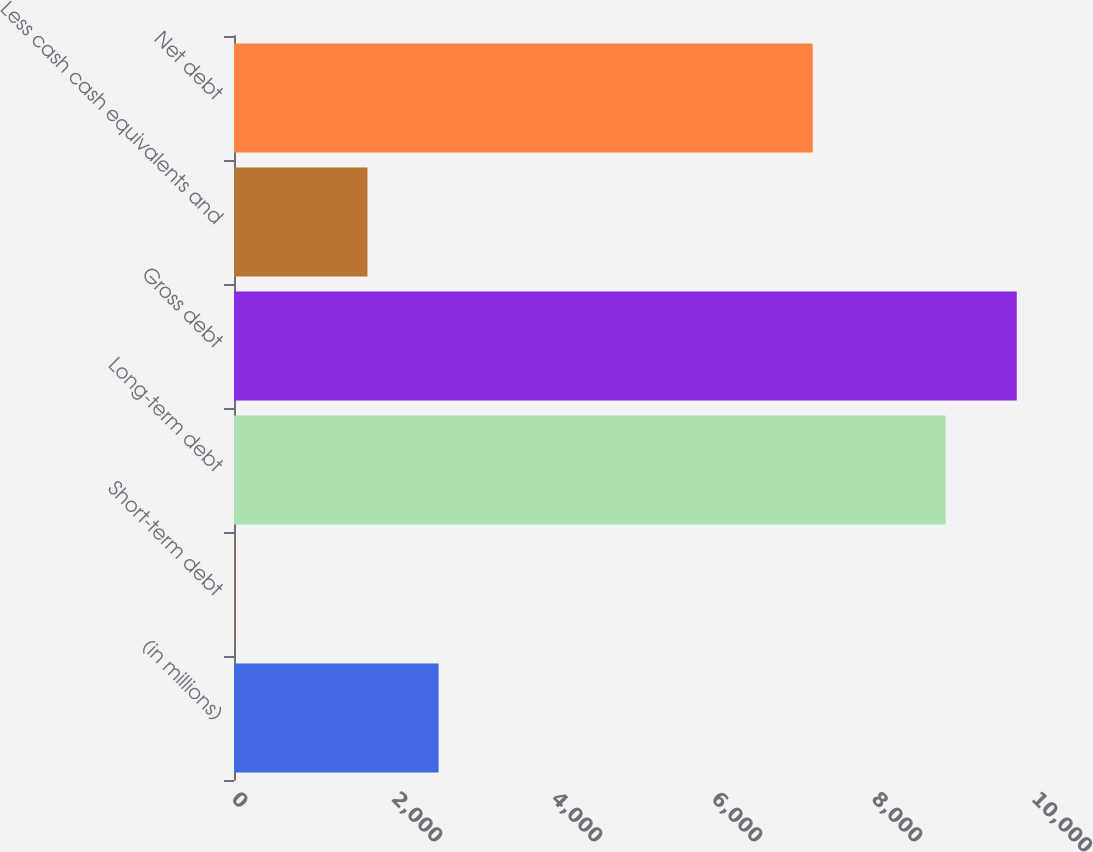<chart> <loc_0><loc_0><loc_500><loc_500><bar_chart><fcel>(in millions)<fcel>Short-term debt<fcel>Long-term debt<fcel>Gross debt<fcel>Less cash cash equivalents and<fcel>Net debt<nl><fcel>2557.5<fcel>7<fcel>8895<fcel>9784.5<fcel>1668<fcel>7234<nl></chart> 